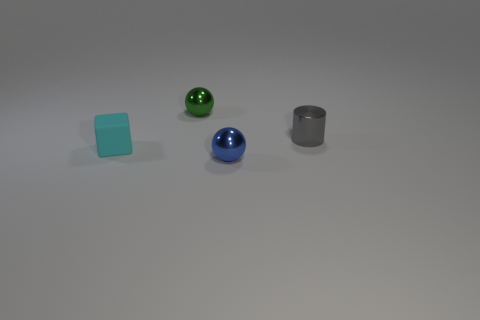Is the material of the blue thing the same as the cyan object?
Your response must be concise. No. Is there anything else that has the same material as the small block?
Give a very brief answer. No. Is the number of cylinders that are on the left side of the green metallic ball less than the number of tiny red objects?
Offer a very short reply. No. There is a tiny cyan matte block; how many small matte blocks are in front of it?
Provide a short and direct response. 0. Is the shape of the small metal object that is in front of the cyan block the same as the green metal thing that is to the right of the cube?
Provide a short and direct response. Yes. What shape is the small metallic thing that is both behind the blue ball and on the right side of the tiny green object?
Provide a short and direct response. Cylinder. The blue ball that is made of the same material as the cylinder is what size?
Make the answer very short. Small. Is the number of things less than the number of small green spheres?
Your response must be concise. No. There is a cyan cube on the left side of the metal ball in front of the small metallic ball that is behind the cyan cube; what is its material?
Your answer should be very brief. Rubber. Does the small ball in front of the small green object have the same material as the small gray cylinder to the right of the cube?
Offer a terse response. Yes. 